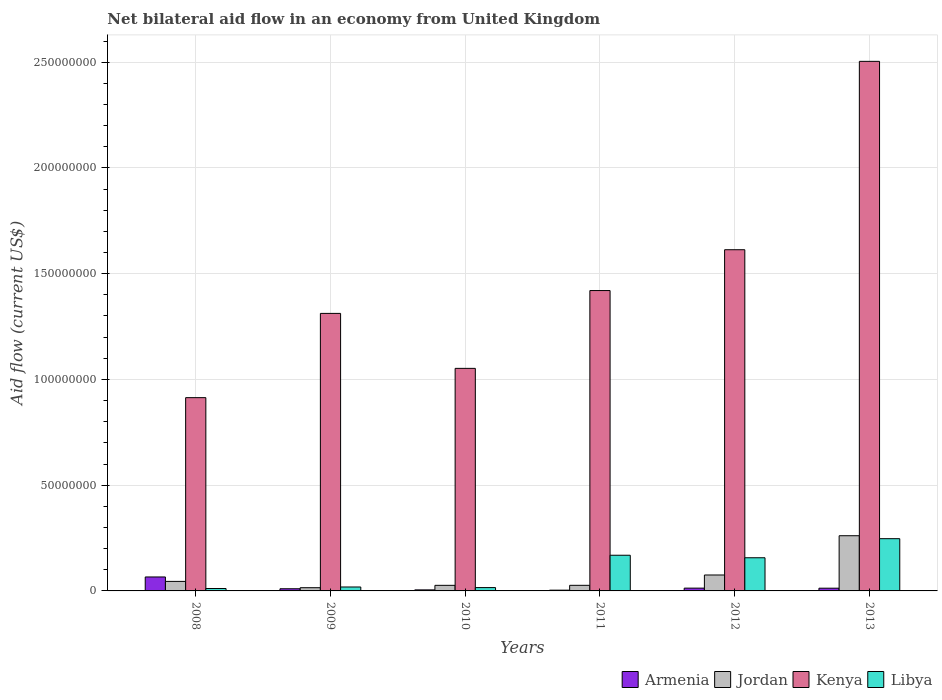How many different coloured bars are there?
Give a very brief answer. 4. How many groups of bars are there?
Keep it short and to the point. 6. Are the number of bars per tick equal to the number of legend labels?
Your answer should be compact. Yes. How many bars are there on the 3rd tick from the left?
Offer a terse response. 4. How many bars are there on the 5th tick from the right?
Offer a very short reply. 4. What is the net bilateral aid flow in Libya in 2009?
Ensure brevity in your answer.  1.86e+06. Across all years, what is the maximum net bilateral aid flow in Jordan?
Provide a short and direct response. 2.61e+07. Across all years, what is the minimum net bilateral aid flow in Jordan?
Provide a short and direct response. 1.52e+06. What is the total net bilateral aid flow in Kenya in the graph?
Give a very brief answer. 8.82e+08. What is the difference between the net bilateral aid flow in Libya in 2008 and that in 2009?
Your answer should be very brief. -7.20e+05. What is the difference between the net bilateral aid flow in Libya in 2012 and the net bilateral aid flow in Armenia in 2013?
Offer a terse response. 1.44e+07. What is the average net bilateral aid flow in Kenya per year?
Make the answer very short. 1.47e+08. In the year 2012, what is the difference between the net bilateral aid flow in Libya and net bilateral aid flow in Jordan?
Provide a succinct answer. 8.15e+06. In how many years, is the net bilateral aid flow in Kenya greater than 50000000 US$?
Keep it short and to the point. 6. What is the ratio of the net bilateral aid flow in Kenya in 2011 to that in 2012?
Your answer should be compact. 0.88. Is the net bilateral aid flow in Jordan in 2010 less than that in 2013?
Keep it short and to the point. Yes. Is the difference between the net bilateral aid flow in Libya in 2011 and 2013 greater than the difference between the net bilateral aid flow in Jordan in 2011 and 2013?
Give a very brief answer. Yes. What is the difference between the highest and the second highest net bilateral aid flow in Kenya?
Your answer should be very brief. 8.91e+07. What is the difference between the highest and the lowest net bilateral aid flow in Libya?
Make the answer very short. 2.36e+07. In how many years, is the net bilateral aid flow in Jordan greater than the average net bilateral aid flow in Jordan taken over all years?
Your answer should be very brief. 2. Is the sum of the net bilateral aid flow in Jordan in 2009 and 2011 greater than the maximum net bilateral aid flow in Armenia across all years?
Provide a short and direct response. No. What does the 4th bar from the left in 2010 represents?
Ensure brevity in your answer.  Libya. What does the 4th bar from the right in 2008 represents?
Your answer should be very brief. Armenia. How many years are there in the graph?
Provide a short and direct response. 6. What is the difference between two consecutive major ticks on the Y-axis?
Provide a short and direct response. 5.00e+07. Does the graph contain any zero values?
Keep it short and to the point. No. What is the title of the graph?
Ensure brevity in your answer.  Net bilateral aid flow in an economy from United Kingdom. Does "St. Lucia" appear as one of the legend labels in the graph?
Ensure brevity in your answer.  No. What is the label or title of the Y-axis?
Offer a very short reply. Aid flow (current US$). What is the Aid flow (current US$) of Armenia in 2008?
Offer a terse response. 6.60e+06. What is the Aid flow (current US$) in Jordan in 2008?
Your answer should be compact. 4.50e+06. What is the Aid flow (current US$) in Kenya in 2008?
Your answer should be compact. 9.14e+07. What is the Aid flow (current US$) in Libya in 2008?
Provide a succinct answer. 1.14e+06. What is the Aid flow (current US$) of Armenia in 2009?
Offer a terse response. 1.02e+06. What is the Aid flow (current US$) of Jordan in 2009?
Offer a terse response. 1.52e+06. What is the Aid flow (current US$) of Kenya in 2009?
Make the answer very short. 1.31e+08. What is the Aid flow (current US$) in Libya in 2009?
Your answer should be very brief. 1.86e+06. What is the Aid flow (current US$) in Jordan in 2010?
Ensure brevity in your answer.  2.64e+06. What is the Aid flow (current US$) of Kenya in 2010?
Ensure brevity in your answer.  1.05e+08. What is the Aid flow (current US$) of Libya in 2010?
Offer a terse response. 1.58e+06. What is the Aid flow (current US$) in Jordan in 2011?
Provide a succinct answer. 2.65e+06. What is the Aid flow (current US$) in Kenya in 2011?
Keep it short and to the point. 1.42e+08. What is the Aid flow (current US$) in Libya in 2011?
Give a very brief answer. 1.69e+07. What is the Aid flow (current US$) of Armenia in 2012?
Offer a very short reply. 1.32e+06. What is the Aid flow (current US$) of Jordan in 2012?
Your answer should be compact. 7.53e+06. What is the Aid flow (current US$) of Kenya in 2012?
Keep it short and to the point. 1.61e+08. What is the Aid flow (current US$) of Libya in 2012?
Keep it short and to the point. 1.57e+07. What is the Aid flow (current US$) in Armenia in 2013?
Your answer should be very brief. 1.29e+06. What is the Aid flow (current US$) of Jordan in 2013?
Your answer should be compact. 2.61e+07. What is the Aid flow (current US$) of Kenya in 2013?
Your answer should be compact. 2.50e+08. What is the Aid flow (current US$) in Libya in 2013?
Your answer should be very brief. 2.47e+07. Across all years, what is the maximum Aid flow (current US$) in Armenia?
Ensure brevity in your answer.  6.60e+06. Across all years, what is the maximum Aid flow (current US$) in Jordan?
Ensure brevity in your answer.  2.61e+07. Across all years, what is the maximum Aid flow (current US$) of Kenya?
Your response must be concise. 2.50e+08. Across all years, what is the maximum Aid flow (current US$) in Libya?
Keep it short and to the point. 2.47e+07. Across all years, what is the minimum Aid flow (current US$) in Jordan?
Offer a very short reply. 1.52e+06. Across all years, what is the minimum Aid flow (current US$) of Kenya?
Your answer should be compact. 9.14e+07. Across all years, what is the minimum Aid flow (current US$) in Libya?
Provide a short and direct response. 1.14e+06. What is the total Aid flow (current US$) in Armenia in the graph?
Ensure brevity in your answer.  1.11e+07. What is the total Aid flow (current US$) of Jordan in the graph?
Your response must be concise. 4.49e+07. What is the total Aid flow (current US$) in Kenya in the graph?
Provide a short and direct response. 8.82e+08. What is the total Aid flow (current US$) in Libya in the graph?
Your answer should be compact. 6.18e+07. What is the difference between the Aid flow (current US$) of Armenia in 2008 and that in 2009?
Provide a short and direct response. 5.58e+06. What is the difference between the Aid flow (current US$) of Jordan in 2008 and that in 2009?
Your answer should be compact. 2.98e+06. What is the difference between the Aid flow (current US$) in Kenya in 2008 and that in 2009?
Give a very brief answer. -3.98e+07. What is the difference between the Aid flow (current US$) in Libya in 2008 and that in 2009?
Offer a terse response. -7.20e+05. What is the difference between the Aid flow (current US$) of Armenia in 2008 and that in 2010?
Give a very brief answer. 6.11e+06. What is the difference between the Aid flow (current US$) in Jordan in 2008 and that in 2010?
Make the answer very short. 1.86e+06. What is the difference between the Aid flow (current US$) of Kenya in 2008 and that in 2010?
Your answer should be very brief. -1.38e+07. What is the difference between the Aid flow (current US$) in Libya in 2008 and that in 2010?
Your response must be concise. -4.40e+05. What is the difference between the Aid flow (current US$) of Armenia in 2008 and that in 2011?
Keep it short and to the point. 6.24e+06. What is the difference between the Aid flow (current US$) of Jordan in 2008 and that in 2011?
Your answer should be compact. 1.85e+06. What is the difference between the Aid flow (current US$) in Kenya in 2008 and that in 2011?
Make the answer very short. -5.06e+07. What is the difference between the Aid flow (current US$) of Libya in 2008 and that in 2011?
Your answer should be very brief. -1.57e+07. What is the difference between the Aid flow (current US$) of Armenia in 2008 and that in 2012?
Offer a very short reply. 5.28e+06. What is the difference between the Aid flow (current US$) in Jordan in 2008 and that in 2012?
Provide a succinct answer. -3.03e+06. What is the difference between the Aid flow (current US$) in Kenya in 2008 and that in 2012?
Make the answer very short. -6.99e+07. What is the difference between the Aid flow (current US$) of Libya in 2008 and that in 2012?
Your answer should be compact. -1.45e+07. What is the difference between the Aid flow (current US$) of Armenia in 2008 and that in 2013?
Give a very brief answer. 5.31e+06. What is the difference between the Aid flow (current US$) in Jordan in 2008 and that in 2013?
Your answer should be compact. -2.16e+07. What is the difference between the Aid flow (current US$) of Kenya in 2008 and that in 2013?
Offer a terse response. -1.59e+08. What is the difference between the Aid flow (current US$) of Libya in 2008 and that in 2013?
Keep it short and to the point. -2.36e+07. What is the difference between the Aid flow (current US$) of Armenia in 2009 and that in 2010?
Your answer should be very brief. 5.30e+05. What is the difference between the Aid flow (current US$) of Jordan in 2009 and that in 2010?
Make the answer very short. -1.12e+06. What is the difference between the Aid flow (current US$) in Kenya in 2009 and that in 2010?
Give a very brief answer. 2.60e+07. What is the difference between the Aid flow (current US$) in Libya in 2009 and that in 2010?
Keep it short and to the point. 2.80e+05. What is the difference between the Aid flow (current US$) in Jordan in 2009 and that in 2011?
Give a very brief answer. -1.13e+06. What is the difference between the Aid flow (current US$) of Kenya in 2009 and that in 2011?
Provide a succinct answer. -1.08e+07. What is the difference between the Aid flow (current US$) of Libya in 2009 and that in 2011?
Offer a very short reply. -1.50e+07. What is the difference between the Aid flow (current US$) in Jordan in 2009 and that in 2012?
Your response must be concise. -6.01e+06. What is the difference between the Aid flow (current US$) in Kenya in 2009 and that in 2012?
Your answer should be compact. -3.01e+07. What is the difference between the Aid flow (current US$) of Libya in 2009 and that in 2012?
Offer a terse response. -1.38e+07. What is the difference between the Aid flow (current US$) in Jordan in 2009 and that in 2013?
Provide a short and direct response. -2.46e+07. What is the difference between the Aid flow (current US$) of Kenya in 2009 and that in 2013?
Ensure brevity in your answer.  -1.19e+08. What is the difference between the Aid flow (current US$) of Libya in 2009 and that in 2013?
Give a very brief answer. -2.28e+07. What is the difference between the Aid flow (current US$) in Armenia in 2010 and that in 2011?
Give a very brief answer. 1.30e+05. What is the difference between the Aid flow (current US$) in Jordan in 2010 and that in 2011?
Offer a very short reply. -10000. What is the difference between the Aid flow (current US$) in Kenya in 2010 and that in 2011?
Keep it short and to the point. -3.68e+07. What is the difference between the Aid flow (current US$) in Libya in 2010 and that in 2011?
Keep it short and to the point. -1.53e+07. What is the difference between the Aid flow (current US$) of Armenia in 2010 and that in 2012?
Keep it short and to the point. -8.30e+05. What is the difference between the Aid flow (current US$) of Jordan in 2010 and that in 2012?
Give a very brief answer. -4.89e+06. What is the difference between the Aid flow (current US$) of Kenya in 2010 and that in 2012?
Your response must be concise. -5.61e+07. What is the difference between the Aid flow (current US$) in Libya in 2010 and that in 2012?
Offer a very short reply. -1.41e+07. What is the difference between the Aid flow (current US$) in Armenia in 2010 and that in 2013?
Offer a terse response. -8.00e+05. What is the difference between the Aid flow (current US$) in Jordan in 2010 and that in 2013?
Your response must be concise. -2.35e+07. What is the difference between the Aid flow (current US$) in Kenya in 2010 and that in 2013?
Your answer should be very brief. -1.45e+08. What is the difference between the Aid flow (current US$) in Libya in 2010 and that in 2013?
Your response must be concise. -2.31e+07. What is the difference between the Aid flow (current US$) in Armenia in 2011 and that in 2012?
Offer a very short reply. -9.60e+05. What is the difference between the Aid flow (current US$) of Jordan in 2011 and that in 2012?
Give a very brief answer. -4.88e+06. What is the difference between the Aid flow (current US$) of Kenya in 2011 and that in 2012?
Your answer should be very brief. -1.93e+07. What is the difference between the Aid flow (current US$) of Libya in 2011 and that in 2012?
Provide a short and direct response. 1.19e+06. What is the difference between the Aid flow (current US$) in Armenia in 2011 and that in 2013?
Provide a succinct answer. -9.30e+05. What is the difference between the Aid flow (current US$) in Jordan in 2011 and that in 2013?
Your response must be concise. -2.34e+07. What is the difference between the Aid flow (current US$) of Kenya in 2011 and that in 2013?
Your response must be concise. -1.08e+08. What is the difference between the Aid flow (current US$) in Libya in 2011 and that in 2013?
Your answer should be very brief. -7.83e+06. What is the difference between the Aid flow (current US$) of Armenia in 2012 and that in 2013?
Offer a very short reply. 3.00e+04. What is the difference between the Aid flow (current US$) of Jordan in 2012 and that in 2013?
Make the answer very short. -1.86e+07. What is the difference between the Aid flow (current US$) of Kenya in 2012 and that in 2013?
Keep it short and to the point. -8.91e+07. What is the difference between the Aid flow (current US$) of Libya in 2012 and that in 2013?
Ensure brevity in your answer.  -9.02e+06. What is the difference between the Aid flow (current US$) in Armenia in 2008 and the Aid flow (current US$) in Jordan in 2009?
Your response must be concise. 5.08e+06. What is the difference between the Aid flow (current US$) in Armenia in 2008 and the Aid flow (current US$) in Kenya in 2009?
Your answer should be very brief. -1.25e+08. What is the difference between the Aid flow (current US$) of Armenia in 2008 and the Aid flow (current US$) of Libya in 2009?
Give a very brief answer. 4.74e+06. What is the difference between the Aid flow (current US$) in Jordan in 2008 and the Aid flow (current US$) in Kenya in 2009?
Your response must be concise. -1.27e+08. What is the difference between the Aid flow (current US$) of Jordan in 2008 and the Aid flow (current US$) of Libya in 2009?
Provide a short and direct response. 2.64e+06. What is the difference between the Aid flow (current US$) in Kenya in 2008 and the Aid flow (current US$) in Libya in 2009?
Give a very brief answer. 8.95e+07. What is the difference between the Aid flow (current US$) of Armenia in 2008 and the Aid flow (current US$) of Jordan in 2010?
Provide a succinct answer. 3.96e+06. What is the difference between the Aid flow (current US$) in Armenia in 2008 and the Aid flow (current US$) in Kenya in 2010?
Keep it short and to the point. -9.86e+07. What is the difference between the Aid flow (current US$) of Armenia in 2008 and the Aid flow (current US$) of Libya in 2010?
Make the answer very short. 5.02e+06. What is the difference between the Aid flow (current US$) of Jordan in 2008 and the Aid flow (current US$) of Kenya in 2010?
Your answer should be very brief. -1.01e+08. What is the difference between the Aid flow (current US$) in Jordan in 2008 and the Aid flow (current US$) in Libya in 2010?
Your answer should be very brief. 2.92e+06. What is the difference between the Aid flow (current US$) in Kenya in 2008 and the Aid flow (current US$) in Libya in 2010?
Provide a succinct answer. 8.98e+07. What is the difference between the Aid flow (current US$) of Armenia in 2008 and the Aid flow (current US$) of Jordan in 2011?
Offer a very short reply. 3.95e+06. What is the difference between the Aid flow (current US$) in Armenia in 2008 and the Aid flow (current US$) in Kenya in 2011?
Offer a very short reply. -1.35e+08. What is the difference between the Aid flow (current US$) of Armenia in 2008 and the Aid flow (current US$) of Libya in 2011?
Make the answer very short. -1.03e+07. What is the difference between the Aid flow (current US$) in Jordan in 2008 and the Aid flow (current US$) in Kenya in 2011?
Offer a terse response. -1.38e+08. What is the difference between the Aid flow (current US$) of Jordan in 2008 and the Aid flow (current US$) of Libya in 2011?
Keep it short and to the point. -1.24e+07. What is the difference between the Aid flow (current US$) in Kenya in 2008 and the Aid flow (current US$) in Libya in 2011?
Your response must be concise. 7.45e+07. What is the difference between the Aid flow (current US$) of Armenia in 2008 and the Aid flow (current US$) of Jordan in 2012?
Keep it short and to the point. -9.30e+05. What is the difference between the Aid flow (current US$) of Armenia in 2008 and the Aid flow (current US$) of Kenya in 2012?
Your answer should be very brief. -1.55e+08. What is the difference between the Aid flow (current US$) in Armenia in 2008 and the Aid flow (current US$) in Libya in 2012?
Your answer should be very brief. -9.08e+06. What is the difference between the Aid flow (current US$) of Jordan in 2008 and the Aid flow (current US$) of Kenya in 2012?
Offer a very short reply. -1.57e+08. What is the difference between the Aid flow (current US$) of Jordan in 2008 and the Aid flow (current US$) of Libya in 2012?
Offer a terse response. -1.12e+07. What is the difference between the Aid flow (current US$) of Kenya in 2008 and the Aid flow (current US$) of Libya in 2012?
Give a very brief answer. 7.57e+07. What is the difference between the Aid flow (current US$) in Armenia in 2008 and the Aid flow (current US$) in Jordan in 2013?
Provide a short and direct response. -1.95e+07. What is the difference between the Aid flow (current US$) in Armenia in 2008 and the Aid flow (current US$) in Kenya in 2013?
Give a very brief answer. -2.44e+08. What is the difference between the Aid flow (current US$) in Armenia in 2008 and the Aid flow (current US$) in Libya in 2013?
Give a very brief answer. -1.81e+07. What is the difference between the Aid flow (current US$) of Jordan in 2008 and the Aid flow (current US$) of Kenya in 2013?
Give a very brief answer. -2.46e+08. What is the difference between the Aid flow (current US$) in Jordan in 2008 and the Aid flow (current US$) in Libya in 2013?
Offer a terse response. -2.02e+07. What is the difference between the Aid flow (current US$) of Kenya in 2008 and the Aid flow (current US$) of Libya in 2013?
Your answer should be very brief. 6.67e+07. What is the difference between the Aid flow (current US$) in Armenia in 2009 and the Aid flow (current US$) in Jordan in 2010?
Offer a very short reply. -1.62e+06. What is the difference between the Aid flow (current US$) of Armenia in 2009 and the Aid flow (current US$) of Kenya in 2010?
Your response must be concise. -1.04e+08. What is the difference between the Aid flow (current US$) in Armenia in 2009 and the Aid flow (current US$) in Libya in 2010?
Your answer should be compact. -5.60e+05. What is the difference between the Aid flow (current US$) in Jordan in 2009 and the Aid flow (current US$) in Kenya in 2010?
Provide a succinct answer. -1.04e+08. What is the difference between the Aid flow (current US$) of Kenya in 2009 and the Aid flow (current US$) of Libya in 2010?
Your answer should be compact. 1.30e+08. What is the difference between the Aid flow (current US$) of Armenia in 2009 and the Aid flow (current US$) of Jordan in 2011?
Make the answer very short. -1.63e+06. What is the difference between the Aid flow (current US$) in Armenia in 2009 and the Aid flow (current US$) in Kenya in 2011?
Your answer should be very brief. -1.41e+08. What is the difference between the Aid flow (current US$) in Armenia in 2009 and the Aid flow (current US$) in Libya in 2011?
Provide a short and direct response. -1.58e+07. What is the difference between the Aid flow (current US$) of Jordan in 2009 and the Aid flow (current US$) of Kenya in 2011?
Provide a short and direct response. -1.40e+08. What is the difference between the Aid flow (current US$) in Jordan in 2009 and the Aid flow (current US$) in Libya in 2011?
Provide a short and direct response. -1.54e+07. What is the difference between the Aid flow (current US$) of Kenya in 2009 and the Aid flow (current US$) of Libya in 2011?
Keep it short and to the point. 1.14e+08. What is the difference between the Aid flow (current US$) of Armenia in 2009 and the Aid flow (current US$) of Jordan in 2012?
Give a very brief answer. -6.51e+06. What is the difference between the Aid flow (current US$) in Armenia in 2009 and the Aid flow (current US$) in Kenya in 2012?
Make the answer very short. -1.60e+08. What is the difference between the Aid flow (current US$) in Armenia in 2009 and the Aid flow (current US$) in Libya in 2012?
Keep it short and to the point. -1.47e+07. What is the difference between the Aid flow (current US$) of Jordan in 2009 and the Aid flow (current US$) of Kenya in 2012?
Make the answer very short. -1.60e+08. What is the difference between the Aid flow (current US$) in Jordan in 2009 and the Aid flow (current US$) in Libya in 2012?
Make the answer very short. -1.42e+07. What is the difference between the Aid flow (current US$) in Kenya in 2009 and the Aid flow (current US$) in Libya in 2012?
Give a very brief answer. 1.16e+08. What is the difference between the Aid flow (current US$) of Armenia in 2009 and the Aid flow (current US$) of Jordan in 2013?
Provide a short and direct response. -2.51e+07. What is the difference between the Aid flow (current US$) in Armenia in 2009 and the Aid flow (current US$) in Kenya in 2013?
Provide a succinct answer. -2.49e+08. What is the difference between the Aid flow (current US$) of Armenia in 2009 and the Aid flow (current US$) of Libya in 2013?
Provide a short and direct response. -2.37e+07. What is the difference between the Aid flow (current US$) of Jordan in 2009 and the Aid flow (current US$) of Kenya in 2013?
Keep it short and to the point. -2.49e+08. What is the difference between the Aid flow (current US$) of Jordan in 2009 and the Aid flow (current US$) of Libya in 2013?
Keep it short and to the point. -2.32e+07. What is the difference between the Aid flow (current US$) in Kenya in 2009 and the Aid flow (current US$) in Libya in 2013?
Your answer should be very brief. 1.07e+08. What is the difference between the Aid flow (current US$) in Armenia in 2010 and the Aid flow (current US$) in Jordan in 2011?
Offer a very short reply. -2.16e+06. What is the difference between the Aid flow (current US$) of Armenia in 2010 and the Aid flow (current US$) of Kenya in 2011?
Provide a short and direct response. -1.42e+08. What is the difference between the Aid flow (current US$) in Armenia in 2010 and the Aid flow (current US$) in Libya in 2011?
Keep it short and to the point. -1.64e+07. What is the difference between the Aid flow (current US$) in Jordan in 2010 and the Aid flow (current US$) in Kenya in 2011?
Provide a short and direct response. -1.39e+08. What is the difference between the Aid flow (current US$) in Jordan in 2010 and the Aid flow (current US$) in Libya in 2011?
Give a very brief answer. -1.42e+07. What is the difference between the Aid flow (current US$) of Kenya in 2010 and the Aid flow (current US$) of Libya in 2011?
Offer a very short reply. 8.84e+07. What is the difference between the Aid flow (current US$) in Armenia in 2010 and the Aid flow (current US$) in Jordan in 2012?
Offer a terse response. -7.04e+06. What is the difference between the Aid flow (current US$) of Armenia in 2010 and the Aid flow (current US$) of Kenya in 2012?
Offer a very short reply. -1.61e+08. What is the difference between the Aid flow (current US$) of Armenia in 2010 and the Aid flow (current US$) of Libya in 2012?
Make the answer very short. -1.52e+07. What is the difference between the Aid flow (current US$) of Jordan in 2010 and the Aid flow (current US$) of Kenya in 2012?
Provide a short and direct response. -1.59e+08. What is the difference between the Aid flow (current US$) of Jordan in 2010 and the Aid flow (current US$) of Libya in 2012?
Ensure brevity in your answer.  -1.30e+07. What is the difference between the Aid flow (current US$) of Kenya in 2010 and the Aid flow (current US$) of Libya in 2012?
Ensure brevity in your answer.  8.96e+07. What is the difference between the Aid flow (current US$) in Armenia in 2010 and the Aid flow (current US$) in Jordan in 2013?
Give a very brief answer. -2.56e+07. What is the difference between the Aid flow (current US$) in Armenia in 2010 and the Aid flow (current US$) in Kenya in 2013?
Your answer should be very brief. -2.50e+08. What is the difference between the Aid flow (current US$) in Armenia in 2010 and the Aid flow (current US$) in Libya in 2013?
Give a very brief answer. -2.42e+07. What is the difference between the Aid flow (current US$) of Jordan in 2010 and the Aid flow (current US$) of Kenya in 2013?
Offer a terse response. -2.48e+08. What is the difference between the Aid flow (current US$) in Jordan in 2010 and the Aid flow (current US$) in Libya in 2013?
Provide a succinct answer. -2.21e+07. What is the difference between the Aid flow (current US$) of Kenya in 2010 and the Aid flow (current US$) of Libya in 2013?
Offer a very short reply. 8.05e+07. What is the difference between the Aid flow (current US$) in Armenia in 2011 and the Aid flow (current US$) in Jordan in 2012?
Make the answer very short. -7.17e+06. What is the difference between the Aid flow (current US$) of Armenia in 2011 and the Aid flow (current US$) of Kenya in 2012?
Offer a terse response. -1.61e+08. What is the difference between the Aid flow (current US$) in Armenia in 2011 and the Aid flow (current US$) in Libya in 2012?
Provide a succinct answer. -1.53e+07. What is the difference between the Aid flow (current US$) of Jordan in 2011 and the Aid flow (current US$) of Kenya in 2012?
Your answer should be very brief. -1.59e+08. What is the difference between the Aid flow (current US$) in Jordan in 2011 and the Aid flow (current US$) in Libya in 2012?
Your answer should be very brief. -1.30e+07. What is the difference between the Aid flow (current US$) of Kenya in 2011 and the Aid flow (current US$) of Libya in 2012?
Keep it short and to the point. 1.26e+08. What is the difference between the Aid flow (current US$) of Armenia in 2011 and the Aid flow (current US$) of Jordan in 2013?
Provide a succinct answer. -2.57e+07. What is the difference between the Aid flow (current US$) in Armenia in 2011 and the Aid flow (current US$) in Kenya in 2013?
Your answer should be very brief. -2.50e+08. What is the difference between the Aid flow (current US$) in Armenia in 2011 and the Aid flow (current US$) in Libya in 2013?
Provide a succinct answer. -2.43e+07. What is the difference between the Aid flow (current US$) in Jordan in 2011 and the Aid flow (current US$) in Kenya in 2013?
Your answer should be very brief. -2.48e+08. What is the difference between the Aid flow (current US$) in Jordan in 2011 and the Aid flow (current US$) in Libya in 2013?
Keep it short and to the point. -2.20e+07. What is the difference between the Aid flow (current US$) in Kenya in 2011 and the Aid flow (current US$) in Libya in 2013?
Keep it short and to the point. 1.17e+08. What is the difference between the Aid flow (current US$) of Armenia in 2012 and the Aid flow (current US$) of Jordan in 2013?
Your answer should be very brief. -2.48e+07. What is the difference between the Aid flow (current US$) in Armenia in 2012 and the Aid flow (current US$) in Kenya in 2013?
Offer a very short reply. -2.49e+08. What is the difference between the Aid flow (current US$) in Armenia in 2012 and the Aid flow (current US$) in Libya in 2013?
Offer a terse response. -2.34e+07. What is the difference between the Aid flow (current US$) in Jordan in 2012 and the Aid flow (current US$) in Kenya in 2013?
Make the answer very short. -2.43e+08. What is the difference between the Aid flow (current US$) of Jordan in 2012 and the Aid flow (current US$) of Libya in 2013?
Provide a short and direct response. -1.72e+07. What is the difference between the Aid flow (current US$) of Kenya in 2012 and the Aid flow (current US$) of Libya in 2013?
Provide a short and direct response. 1.37e+08. What is the average Aid flow (current US$) in Armenia per year?
Provide a succinct answer. 1.85e+06. What is the average Aid flow (current US$) in Jordan per year?
Offer a very short reply. 7.49e+06. What is the average Aid flow (current US$) of Kenya per year?
Your answer should be compact. 1.47e+08. What is the average Aid flow (current US$) of Libya per year?
Provide a short and direct response. 1.03e+07. In the year 2008, what is the difference between the Aid flow (current US$) in Armenia and Aid flow (current US$) in Jordan?
Your answer should be very brief. 2.10e+06. In the year 2008, what is the difference between the Aid flow (current US$) in Armenia and Aid flow (current US$) in Kenya?
Keep it short and to the point. -8.48e+07. In the year 2008, what is the difference between the Aid flow (current US$) in Armenia and Aid flow (current US$) in Libya?
Your answer should be very brief. 5.46e+06. In the year 2008, what is the difference between the Aid flow (current US$) in Jordan and Aid flow (current US$) in Kenya?
Your response must be concise. -8.69e+07. In the year 2008, what is the difference between the Aid flow (current US$) of Jordan and Aid flow (current US$) of Libya?
Provide a short and direct response. 3.36e+06. In the year 2008, what is the difference between the Aid flow (current US$) in Kenya and Aid flow (current US$) in Libya?
Your answer should be very brief. 9.02e+07. In the year 2009, what is the difference between the Aid flow (current US$) of Armenia and Aid flow (current US$) of Jordan?
Offer a very short reply. -5.00e+05. In the year 2009, what is the difference between the Aid flow (current US$) in Armenia and Aid flow (current US$) in Kenya?
Make the answer very short. -1.30e+08. In the year 2009, what is the difference between the Aid flow (current US$) of Armenia and Aid flow (current US$) of Libya?
Keep it short and to the point. -8.40e+05. In the year 2009, what is the difference between the Aid flow (current US$) in Jordan and Aid flow (current US$) in Kenya?
Your answer should be very brief. -1.30e+08. In the year 2009, what is the difference between the Aid flow (current US$) in Kenya and Aid flow (current US$) in Libya?
Give a very brief answer. 1.29e+08. In the year 2010, what is the difference between the Aid flow (current US$) in Armenia and Aid flow (current US$) in Jordan?
Ensure brevity in your answer.  -2.15e+06. In the year 2010, what is the difference between the Aid flow (current US$) of Armenia and Aid flow (current US$) of Kenya?
Make the answer very short. -1.05e+08. In the year 2010, what is the difference between the Aid flow (current US$) of Armenia and Aid flow (current US$) of Libya?
Your answer should be compact. -1.09e+06. In the year 2010, what is the difference between the Aid flow (current US$) in Jordan and Aid flow (current US$) in Kenya?
Provide a succinct answer. -1.03e+08. In the year 2010, what is the difference between the Aid flow (current US$) of Jordan and Aid flow (current US$) of Libya?
Your answer should be compact. 1.06e+06. In the year 2010, what is the difference between the Aid flow (current US$) of Kenya and Aid flow (current US$) of Libya?
Your answer should be compact. 1.04e+08. In the year 2011, what is the difference between the Aid flow (current US$) of Armenia and Aid flow (current US$) of Jordan?
Provide a short and direct response. -2.29e+06. In the year 2011, what is the difference between the Aid flow (current US$) in Armenia and Aid flow (current US$) in Kenya?
Give a very brief answer. -1.42e+08. In the year 2011, what is the difference between the Aid flow (current US$) in Armenia and Aid flow (current US$) in Libya?
Keep it short and to the point. -1.65e+07. In the year 2011, what is the difference between the Aid flow (current US$) of Jordan and Aid flow (current US$) of Kenya?
Give a very brief answer. -1.39e+08. In the year 2011, what is the difference between the Aid flow (current US$) in Jordan and Aid flow (current US$) in Libya?
Give a very brief answer. -1.42e+07. In the year 2011, what is the difference between the Aid flow (current US$) of Kenya and Aid flow (current US$) of Libya?
Your answer should be compact. 1.25e+08. In the year 2012, what is the difference between the Aid flow (current US$) in Armenia and Aid flow (current US$) in Jordan?
Provide a short and direct response. -6.21e+06. In the year 2012, what is the difference between the Aid flow (current US$) in Armenia and Aid flow (current US$) in Kenya?
Your response must be concise. -1.60e+08. In the year 2012, what is the difference between the Aid flow (current US$) in Armenia and Aid flow (current US$) in Libya?
Ensure brevity in your answer.  -1.44e+07. In the year 2012, what is the difference between the Aid flow (current US$) in Jordan and Aid flow (current US$) in Kenya?
Keep it short and to the point. -1.54e+08. In the year 2012, what is the difference between the Aid flow (current US$) in Jordan and Aid flow (current US$) in Libya?
Keep it short and to the point. -8.15e+06. In the year 2012, what is the difference between the Aid flow (current US$) in Kenya and Aid flow (current US$) in Libya?
Ensure brevity in your answer.  1.46e+08. In the year 2013, what is the difference between the Aid flow (current US$) of Armenia and Aid flow (current US$) of Jordan?
Ensure brevity in your answer.  -2.48e+07. In the year 2013, what is the difference between the Aid flow (current US$) in Armenia and Aid flow (current US$) in Kenya?
Give a very brief answer. -2.49e+08. In the year 2013, what is the difference between the Aid flow (current US$) of Armenia and Aid flow (current US$) of Libya?
Offer a very short reply. -2.34e+07. In the year 2013, what is the difference between the Aid flow (current US$) in Jordan and Aid flow (current US$) in Kenya?
Offer a very short reply. -2.24e+08. In the year 2013, what is the difference between the Aid flow (current US$) of Jordan and Aid flow (current US$) of Libya?
Provide a succinct answer. 1.40e+06. In the year 2013, what is the difference between the Aid flow (current US$) in Kenya and Aid flow (current US$) in Libya?
Your response must be concise. 2.26e+08. What is the ratio of the Aid flow (current US$) in Armenia in 2008 to that in 2009?
Provide a succinct answer. 6.47. What is the ratio of the Aid flow (current US$) in Jordan in 2008 to that in 2009?
Give a very brief answer. 2.96. What is the ratio of the Aid flow (current US$) of Kenya in 2008 to that in 2009?
Your answer should be very brief. 0.7. What is the ratio of the Aid flow (current US$) of Libya in 2008 to that in 2009?
Ensure brevity in your answer.  0.61. What is the ratio of the Aid flow (current US$) of Armenia in 2008 to that in 2010?
Give a very brief answer. 13.47. What is the ratio of the Aid flow (current US$) in Jordan in 2008 to that in 2010?
Provide a short and direct response. 1.7. What is the ratio of the Aid flow (current US$) in Kenya in 2008 to that in 2010?
Keep it short and to the point. 0.87. What is the ratio of the Aid flow (current US$) in Libya in 2008 to that in 2010?
Give a very brief answer. 0.72. What is the ratio of the Aid flow (current US$) of Armenia in 2008 to that in 2011?
Your answer should be very brief. 18.33. What is the ratio of the Aid flow (current US$) of Jordan in 2008 to that in 2011?
Your answer should be very brief. 1.7. What is the ratio of the Aid flow (current US$) in Kenya in 2008 to that in 2011?
Offer a very short reply. 0.64. What is the ratio of the Aid flow (current US$) of Libya in 2008 to that in 2011?
Offer a very short reply. 0.07. What is the ratio of the Aid flow (current US$) of Armenia in 2008 to that in 2012?
Offer a terse response. 5. What is the ratio of the Aid flow (current US$) in Jordan in 2008 to that in 2012?
Your answer should be very brief. 0.6. What is the ratio of the Aid flow (current US$) in Kenya in 2008 to that in 2012?
Offer a terse response. 0.57. What is the ratio of the Aid flow (current US$) of Libya in 2008 to that in 2012?
Make the answer very short. 0.07. What is the ratio of the Aid flow (current US$) in Armenia in 2008 to that in 2013?
Ensure brevity in your answer.  5.12. What is the ratio of the Aid flow (current US$) of Jordan in 2008 to that in 2013?
Ensure brevity in your answer.  0.17. What is the ratio of the Aid flow (current US$) of Kenya in 2008 to that in 2013?
Make the answer very short. 0.36. What is the ratio of the Aid flow (current US$) of Libya in 2008 to that in 2013?
Give a very brief answer. 0.05. What is the ratio of the Aid flow (current US$) of Armenia in 2009 to that in 2010?
Offer a very short reply. 2.08. What is the ratio of the Aid flow (current US$) of Jordan in 2009 to that in 2010?
Your answer should be compact. 0.58. What is the ratio of the Aid flow (current US$) of Kenya in 2009 to that in 2010?
Make the answer very short. 1.25. What is the ratio of the Aid flow (current US$) of Libya in 2009 to that in 2010?
Your answer should be very brief. 1.18. What is the ratio of the Aid flow (current US$) of Armenia in 2009 to that in 2011?
Your answer should be compact. 2.83. What is the ratio of the Aid flow (current US$) of Jordan in 2009 to that in 2011?
Provide a short and direct response. 0.57. What is the ratio of the Aid flow (current US$) in Kenya in 2009 to that in 2011?
Your response must be concise. 0.92. What is the ratio of the Aid flow (current US$) in Libya in 2009 to that in 2011?
Your answer should be very brief. 0.11. What is the ratio of the Aid flow (current US$) in Armenia in 2009 to that in 2012?
Offer a very short reply. 0.77. What is the ratio of the Aid flow (current US$) of Jordan in 2009 to that in 2012?
Give a very brief answer. 0.2. What is the ratio of the Aid flow (current US$) of Kenya in 2009 to that in 2012?
Give a very brief answer. 0.81. What is the ratio of the Aid flow (current US$) in Libya in 2009 to that in 2012?
Keep it short and to the point. 0.12. What is the ratio of the Aid flow (current US$) in Armenia in 2009 to that in 2013?
Offer a terse response. 0.79. What is the ratio of the Aid flow (current US$) in Jordan in 2009 to that in 2013?
Your response must be concise. 0.06. What is the ratio of the Aid flow (current US$) in Kenya in 2009 to that in 2013?
Offer a terse response. 0.52. What is the ratio of the Aid flow (current US$) of Libya in 2009 to that in 2013?
Give a very brief answer. 0.08. What is the ratio of the Aid flow (current US$) in Armenia in 2010 to that in 2011?
Your answer should be very brief. 1.36. What is the ratio of the Aid flow (current US$) of Kenya in 2010 to that in 2011?
Your answer should be compact. 0.74. What is the ratio of the Aid flow (current US$) in Libya in 2010 to that in 2011?
Provide a short and direct response. 0.09. What is the ratio of the Aid flow (current US$) in Armenia in 2010 to that in 2012?
Ensure brevity in your answer.  0.37. What is the ratio of the Aid flow (current US$) in Jordan in 2010 to that in 2012?
Keep it short and to the point. 0.35. What is the ratio of the Aid flow (current US$) of Kenya in 2010 to that in 2012?
Offer a terse response. 0.65. What is the ratio of the Aid flow (current US$) in Libya in 2010 to that in 2012?
Give a very brief answer. 0.1. What is the ratio of the Aid flow (current US$) of Armenia in 2010 to that in 2013?
Provide a succinct answer. 0.38. What is the ratio of the Aid flow (current US$) in Jordan in 2010 to that in 2013?
Provide a succinct answer. 0.1. What is the ratio of the Aid flow (current US$) of Kenya in 2010 to that in 2013?
Your answer should be very brief. 0.42. What is the ratio of the Aid flow (current US$) in Libya in 2010 to that in 2013?
Provide a short and direct response. 0.06. What is the ratio of the Aid flow (current US$) in Armenia in 2011 to that in 2012?
Offer a terse response. 0.27. What is the ratio of the Aid flow (current US$) in Jordan in 2011 to that in 2012?
Ensure brevity in your answer.  0.35. What is the ratio of the Aid flow (current US$) of Kenya in 2011 to that in 2012?
Give a very brief answer. 0.88. What is the ratio of the Aid flow (current US$) in Libya in 2011 to that in 2012?
Offer a terse response. 1.08. What is the ratio of the Aid flow (current US$) in Armenia in 2011 to that in 2013?
Your answer should be very brief. 0.28. What is the ratio of the Aid flow (current US$) of Jordan in 2011 to that in 2013?
Ensure brevity in your answer.  0.1. What is the ratio of the Aid flow (current US$) of Kenya in 2011 to that in 2013?
Your response must be concise. 0.57. What is the ratio of the Aid flow (current US$) in Libya in 2011 to that in 2013?
Ensure brevity in your answer.  0.68. What is the ratio of the Aid flow (current US$) in Armenia in 2012 to that in 2013?
Provide a succinct answer. 1.02. What is the ratio of the Aid flow (current US$) in Jordan in 2012 to that in 2013?
Offer a very short reply. 0.29. What is the ratio of the Aid flow (current US$) of Kenya in 2012 to that in 2013?
Keep it short and to the point. 0.64. What is the ratio of the Aid flow (current US$) in Libya in 2012 to that in 2013?
Your answer should be compact. 0.63. What is the difference between the highest and the second highest Aid flow (current US$) in Armenia?
Make the answer very short. 5.28e+06. What is the difference between the highest and the second highest Aid flow (current US$) of Jordan?
Make the answer very short. 1.86e+07. What is the difference between the highest and the second highest Aid flow (current US$) in Kenya?
Give a very brief answer. 8.91e+07. What is the difference between the highest and the second highest Aid flow (current US$) in Libya?
Keep it short and to the point. 7.83e+06. What is the difference between the highest and the lowest Aid flow (current US$) of Armenia?
Give a very brief answer. 6.24e+06. What is the difference between the highest and the lowest Aid flow (current US$) of Jordan?
Give a very brief answer. 2.46e+07. What is the difference between the highest and the lowest Aid flow (current US$) of Kenya?
Your response must be concise. 1.59e+08. What is the difference between the highest and the lowest Aid flow (current US$) in Libya?
Provide a succinct answer. 2.36e+07. 